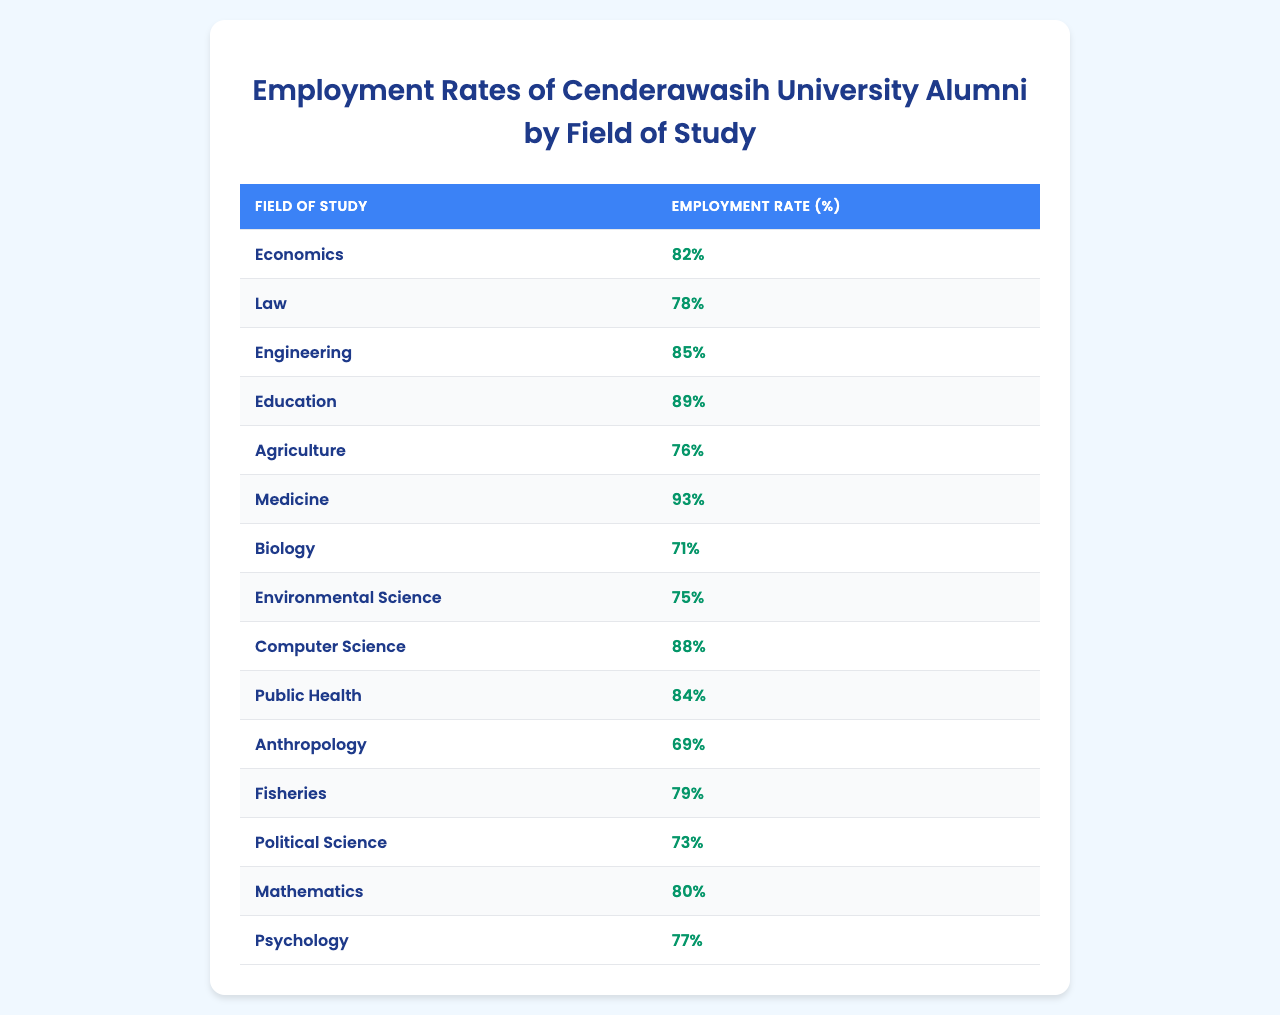What is the employment rate for graduates in Medicine? From the table, the employment rate specifically listed for the field of Medicine is 93%.
Answer: 93% Which field of study has the highest employment rate among Cenderawasih University alumni? By comparing the employment rates provided in the table, Engineering (85%) is the highest rate among all fields listed.
Answer: Engineering What is the average employment rate of the alumni from fields in Science (Biology, Environmental Science, and Computer Science)? To find the average for these three fields, sum the employment rates: 71% (Biology) + 75% (Environmental Science) + 88% (Computer Science) = 234%. Then, divide by 3 to get the average: 234% / 3 = 78%.
Answer: 78% Do more than half of the fields listed have an employment rate above 80%? There are 15 fields listed. The fields with rates above 80% are Economics, Engineering, Education, Medicine, Computer Science, and Public Health (total of 6), which is indeed more than half.
Answer: Yes What is the difference in employment rates between the highest and lowest fields of study? The highest employment rate is for Medicine (93%) and the lowest for Anthropology (69%). The difference is calculated as: 93% - 69% = 24%.
Answer: 24% Which field of study has an employment rate of 76%? According to the table, the field of Agriculture has an employment rate of 76%.
Answer: Agriculture Is the employment rate for Psychology higher than 80%? From the table, the employment rate for Psychology is 77%, which is below 80%.
Answer: No What is the median employment rate among the fields of study listed? To find the median, we sort the rates: 69, 71, 73, 75, 76, 77, 78, 80, 82, 84, 85, 88, 89, 93. In sorted order, there are 15 numbers, and the median is the 8th number, which is 80%.
Answer: 80% 